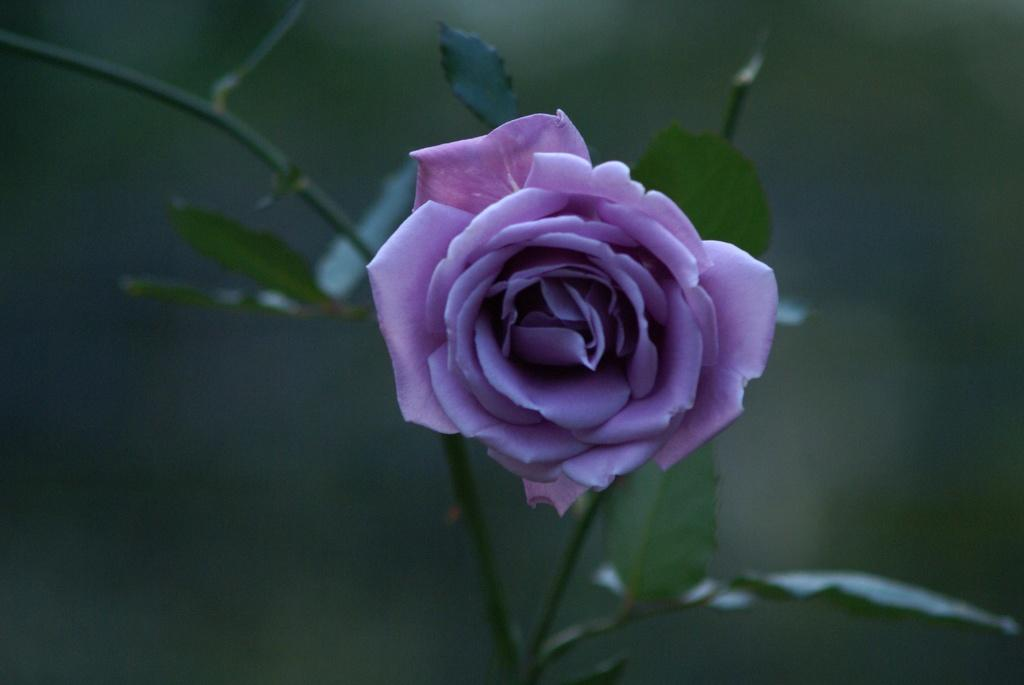What is the main subject of the image? There is a flower in the image. What else can be seen in the image besides the flower? There are leaves in the image. How would you describe the background of the image? The background of the image is blurry. How much salt is sprinkled on the flower in the image? There is no salt present in the image, as it features a flower and leaves with a blurry background. 